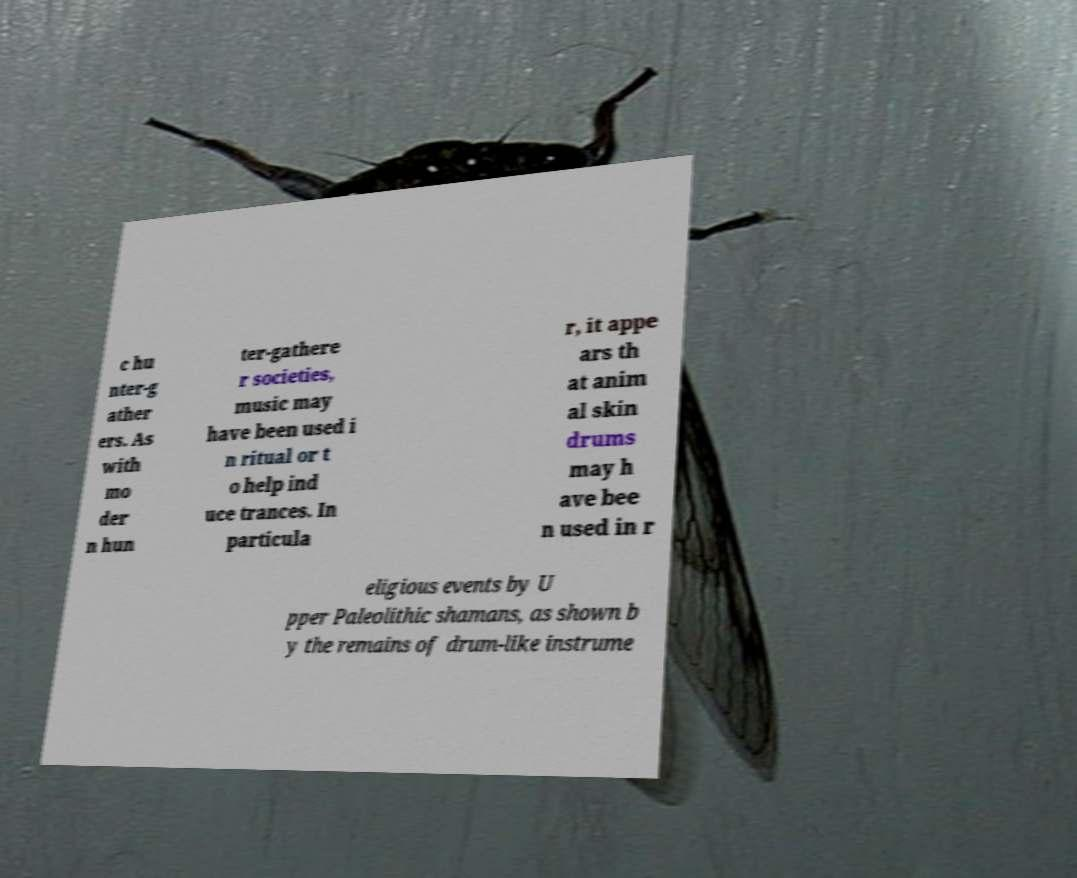There's text embedded in this image that I need extracted. Can you transcribe it verbatim? c hu nter-g ather ers. As with mo der n hun ter-gathere r societies, music may have been used i n ritual or t o help ind uce trances. In particula r, it appe ars th at anim al skin drums may h ave bee n used in r eligious events by U pper Paleolithic shamans, as shown b y the remains of drum-like instrume 